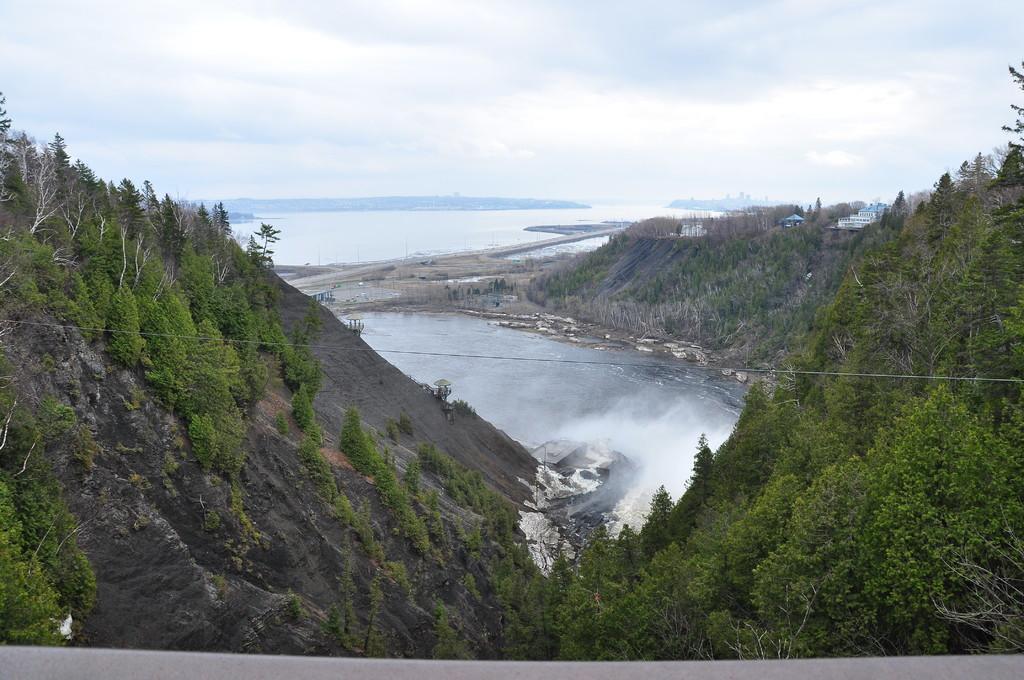In one or two sentences, can you explain what this image depicts? In the center of the image we can see mountains, trees, water are there. On the right side of the image we can see some buildings are there. At the top of the image clouds are present in the sky. 